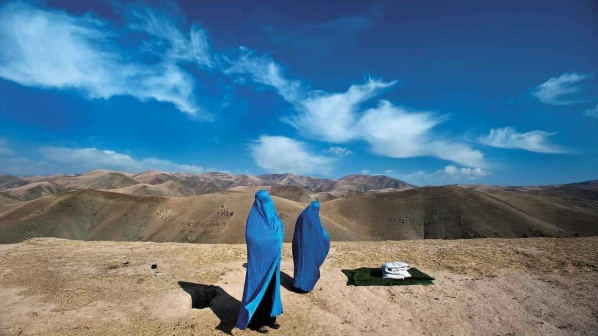What made the spot they chose to stop at so significant in their journey? This particular hilltop provided an ideal vantage point, offering both a physical rest and a mental reprieve. The panoramic view of the undulating mountains stretching out before them symbolized both the challenges they had overcome and the journey still ahead. The decision to pause at this spot was symbolic of acknowledging their progress while mentally preparing for the unknown paths yet to be traversed.

Their stop also allowed for a reflective moment to appreciate the beauty of the natural world, a reminder of the reasons they embarked on this journey in the first place. Conversations here might have been deeper, more introspective, and filled with a renewed sense of purpose. The clear blue sky with its whispers of clouds added a sense of tranquility, reinforcing the significance of this serene pause in their demanding pilgrimage. The presence of Noor, their loyal companion, provided an added layer of comfort and security, making this stop not only significant but essential for their physical and spiritual well-being. 